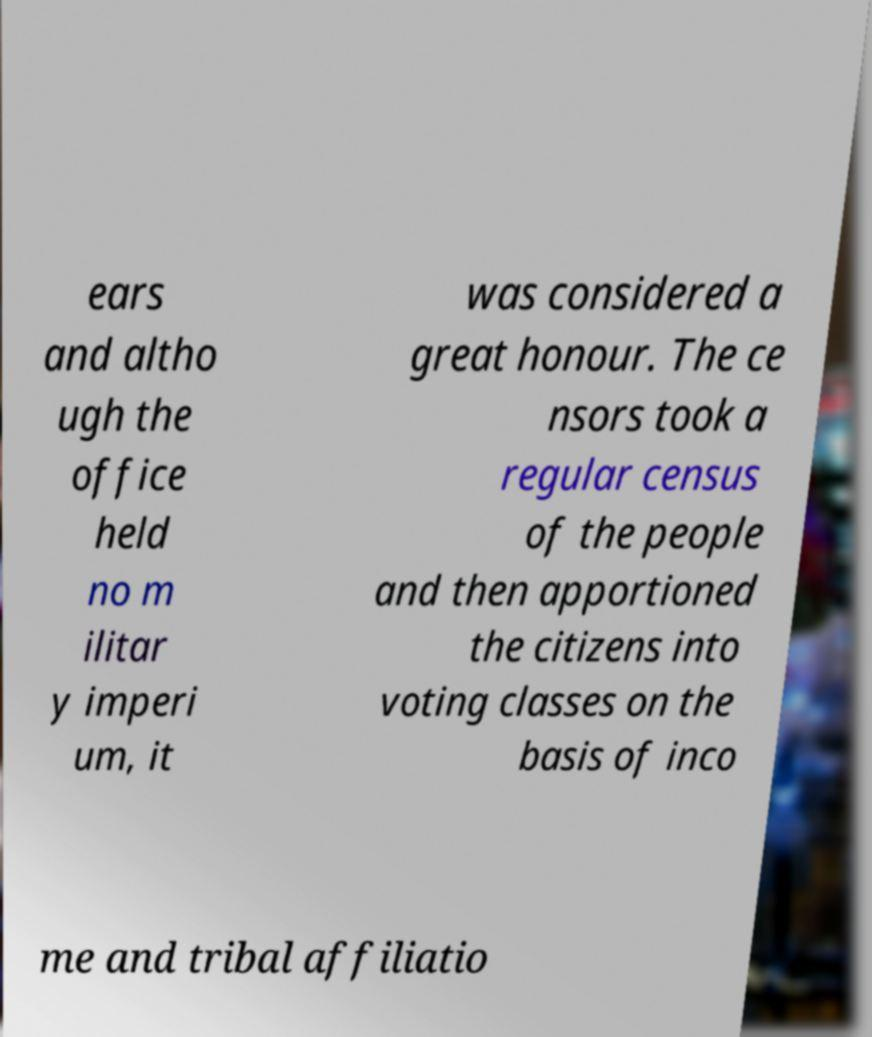For documentation purposes, I need the text within this image transcribed. Could you provide that? ears and altho ugh the office held no m ilitar y imperi um, it was considered a great honour. The ce nsors took a regular census of the people and then apportioned the citizens into voting classes on the basis of inco me and tribal affiliatio 